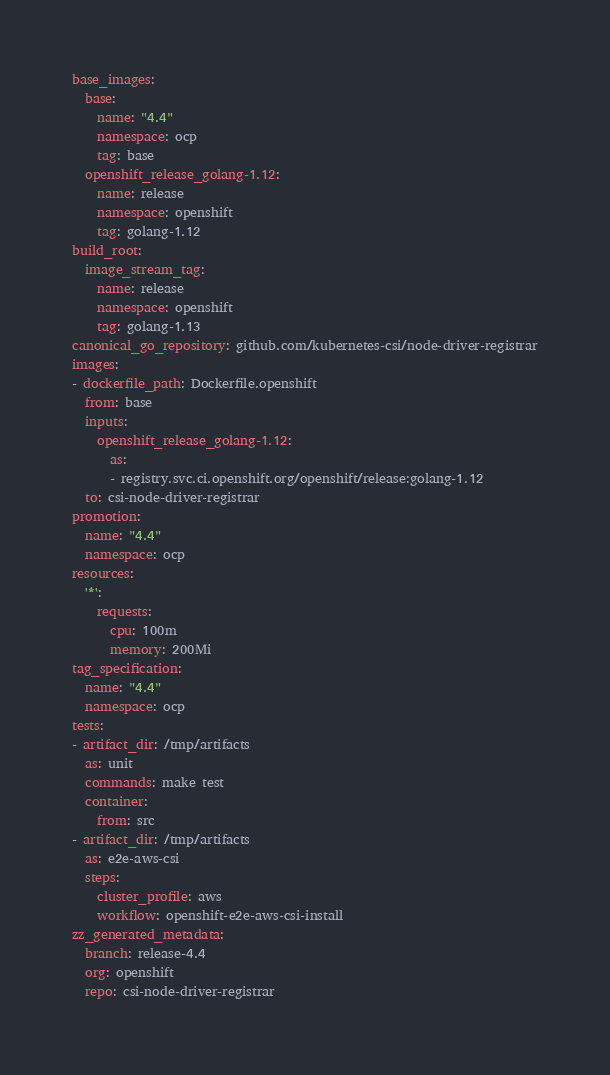Convert code to text. <code><loc_0><loc_0><loc_500><loc_500><_YAML_>base_images:
  base:
    name: "4.4"
    namespace: ocp
    tag: base
  openshift_release_golang-1.12:
    name: release
    namespace: openshift
    tag: golang-1.12
build_root:
  image_stream_tag:
    name: release
    namespace: openshift
    tag: golang-1.13
canonical_go_repository: github.com/kubernetes-csi/node-driver-registrar
images:
- dockerfile_path: Dockerfile.openshift
  from: base
  inputs:
    openshift_release_golang-1.12:
      as:
      - registry.svc.ci.openshift.org/openshift/release:golang-1.12
  to: csi-node-driver-registrar
promotion:
  name: "4.4"
  namespace: ocp
resources:
  '*':
    requests:
      cpu: 100m
      memory: 200Mi
tag_specification:
  name: "4.4"
  namespace: ocp
tests:
- artifact_dir: /tmp/artifacts
  as: unit
  commands: make test
  container:
    from: src
- artifact_dir: /tmp/artifacts
  as: e2e-aws-csi
  steps:
    cluster_profile: aws
    workflow: openshift-e2e-aws-csi-install
zz_generated_metadata:
  branch: release-4.4
  org: openshift
  repo: csi-node-driver-registrar
</code> 